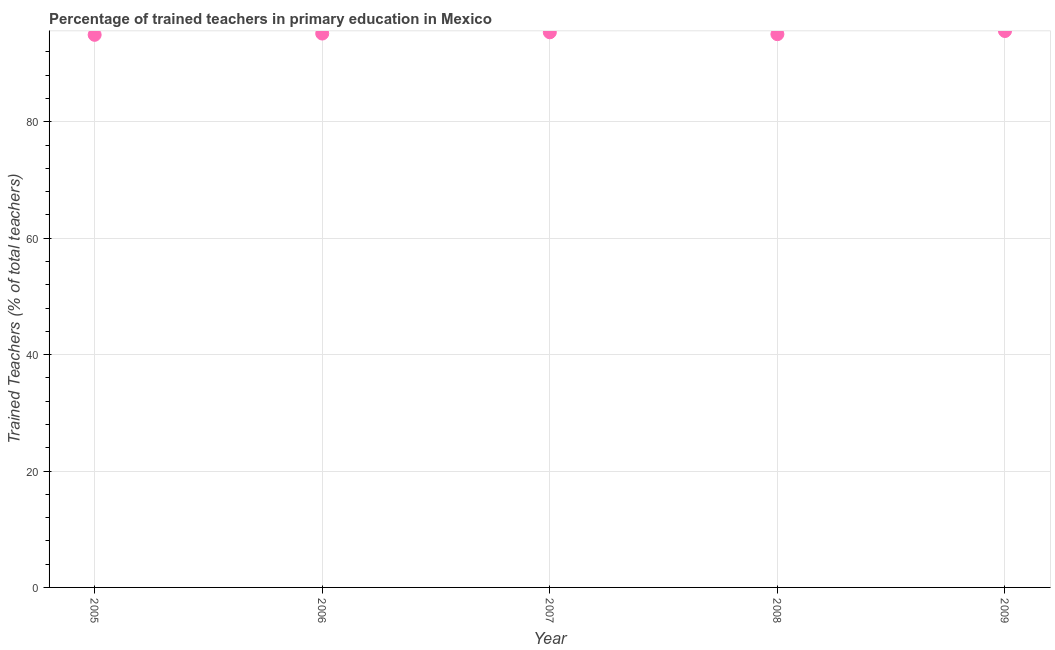What is the percentage of trained teachers in 2007?
Your response must be concise. 95.37. Across all years, what is the maximum percentage of trained teachers?
Offer a very short reply. 95.59. Across all years, what is the minimum percentage of trained teachers?
Your response must be concise. 94.93. In which year was the percentage of trained teachers minimum?
Your answer should be very brief. 2005. What is the sum of the percentage of trained teachers?
Keep it short and to the point. 476.09. What is the difference between the percentage of trained teachers in 2005 and 2009?
Your response must be concise. -0.65. What is the average percentage of trained teachers per year?
Your answer should be compact. 95.22. What is the median percentage of trained teachers?
Your answer should be very brief. 95.15. In how many years, is the percentage of trained teachers greater than 80 %?
Provide a succinct answer. 5. Do a majority of the years between 2009 and 2007 (inclusive) have percentage of trained teachers greater than 48 %?
Your response must be concise. No. What is the ratio of the percentage of trained teachers in 2005 to that in 2008?
Keep it short and to the point. 1. Is the difference between the percentage of trained teachers in 2008 and 2009 greater than the difference between any two years?
Ensure brevity in your answer.  No. What is the difference between the highest and the second highest percentage of trained teachers?
Make the answer very short. 0.22. Is the sum of the percentage of trained teachers in 2007 and 2008 greater than the maximum percentage of trained teachers across all years?
Your response must be concise. Yes. What is the difference between the highest and the lowest percentage of trained teachers?
Give a very brief answer. 0.65. How many years are there in the graph?
Make the answer very short. 5. What is the difference between two consecutive major ticks on the Y-axis?
Offer a terse response. 20. Are the values on the major ticks of Y-axis written in scientific E-notation?
Make the answer very short. No. What is the title of the graph?
Provide a succinct answer. Percentage of trained teachers in primary education in Mexico. What is the label or title of the Y-axis?
Provide a succinct answer. Trained Teachers (% of total teachers). What is the Trained Teachers (% of total teachers) in 2005?
Provide a short and direct response. 94.93. What is the Trained Teachers (% of total teachers) in 2006?
Keep it short and to the point. 95.15. What is the Trained Teachers (% of total teachers) in 2007?
Offer a very short reply. 95.37. What is the Trained Teachers (% of total teachers) in 2008?
Provide a short and direct response. 95.05. What is the Trained Teachers (% of total teachers) in 2009?
Offer a very short reply. 95.59. What is the difference between the Trained Teachers (% of total teachers) in 2005 and 2006?
Make the answer very short. -0.22. What is the difference between the Trained Teachers (% of total teachers) in 2005 and 2007?
Offer a very short reply. -0.43. What is the difference between the Trained Teachers (% of total teachers) in 2005 and 2008?
Keep it short and to the point. -0.11. What is the difference between the Trained Teachers (% of total teachers) in 2005 and 2009?
Keep it short and to the point. -0.65. What is the difference between the Trained Teachers (% of total teachers) in 2006 and 2007?
Make the answer very short. -0.22. What is the difference between the Trained Teachers (% of total teachers) in 2006 and 2008?
Ensure brevity in your answer.  0.11. What is the difference between the Trained Teachers (% of total teachers) in 2006 and 2009?
Provide a succinct answer. -0.43. What is the difference between the Trained Teachers (% of total teachers) in 2007 and 2008?
Keep it short and to the point. 0.32. What is the difference between the Trained Teachers (% of total teachers) in 2007 and 2009?
Keep it short and to the point. -0.22. What is the difference between the Trained Teachers (% of total teachers) in 2008 and 2009?
Offer a very short reply. -0.54. What is the ratio of the Trained Teachers (% of total teachers) in 2005 to that in 2008?
Your response must be concise. 1. What is the ratio of the Trained Teachers (% of total teachers) in 2006 to that in 2009?
Offer a terse response. 0.99. What is the ratio of the Trained Teachers (% of total teachers) in 2007 to that in 2009?
Keep it short and to the point. 1. What is the ratio of the Trained Teachers (% of total teachers) in 2008 to that in 2009?
Offer a very short reply. 0.99. 